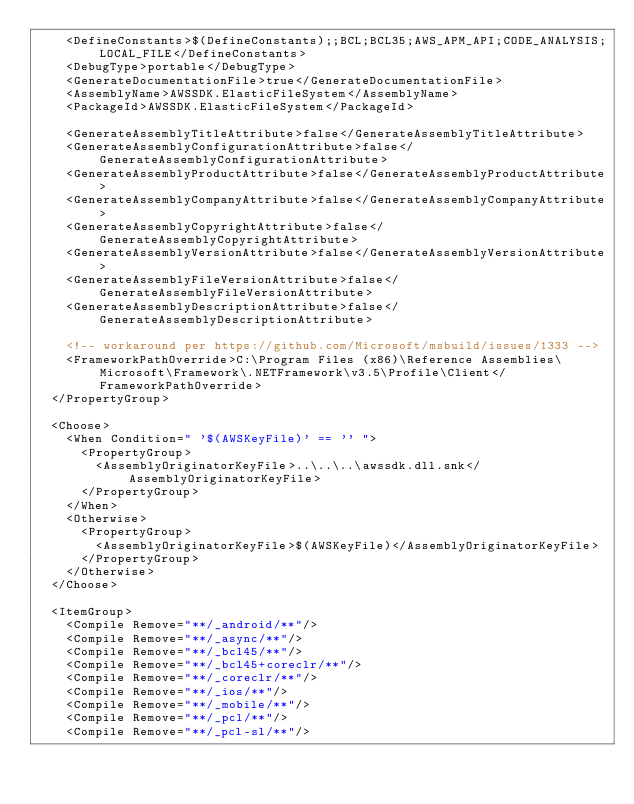Convert code to text. <code><loc_0><loc_0><loc_500><loc_500><_XML_>    <DefineConstants>$(DefineConstants);;BCL;BCL35;AWS_APM_API;CODE_ANALYSIS;LOCAL_FILE</DefineConstants>
    <DebugType>portable</DebugType>
    <GenerateDocumentationFile>true</GenerateDocumentationFile>
    <AssemblyName>AWSSDK.ElasticFileSystem</AssemblyName>
    <PackageId>AWSSDK.ElasticFileSystem</PackageId>

    <GenerateAssemblyTitleAttribute>false</GenerateAssemblyTitleAttribute>
    <GenerateAssemblyConfigurationAttribute>false</GenerateAssemblyConfigurationAttribute>
    <GenerateAssemblyProductAttribute>false</GenerateAssemblyProductAttribute>
    <GenerateAssemblyCompanyAttribute>false</GenerateAssemblyCompanyAttribute>
    <GenerateAssemblyCopyrightAttribute>false</GenerateAssemblyCopyrightAttribute>
    <GenerateAssemblyVersionAttribute>false</GenerateAssemblyVersionAttribute>
    <GenerateAssemblyFileVersionAttribute>false</GenerateAssemblyFileVersionAttribute>
    <GenerateAssemblyDescriptionAttribute>false</GenerateAssemblyDescriptionAttribute>

    <!-- workaround per https://github.com/Microsoft/msbuild/issues/1333 -->
    <FrameworkPathOverride>C:\Program Files (x86)\Reference Assemblies\Microsoft\Framework\.NETFramework\v3.5\Profile\Client</FrameworkPathOverride>
  </PropertyGroup>

  <Choose>
    <When Condition=" '$(AWSKeyFile)' == '' ">
      <PropertyGroup>
        <AssemblyOriginatorKeyFile>..\..\..\awssdk.dll.snk</AssemblyOriginatorKeyFile>
      </PropertyGroup>
    </When>
    <Otherwise>
      <PropertyGroup>
        <AssemblyOriginatorKeyFile>$(AWSKeyFile)</AssemblyOriginatorKeyFile>
      </PropertyGroup>
    </Otherwise>
  </Choose>

  <ItemGroup>
    <Compile Remove="**/_android/**"/>
    <Compile Remove="**/_async/**"/>
    <Compile Remove="**/_bcl45/**"/>
    <Compile Remove="**/_bcl45+coreclr/**"/>
    <Compile Remove="**/_coreclr/**"/>
    <Compile Remove="**/_ios/**"/>
    <Compile Remove="**/_mobile/**"/>
    <Compile Remove="**/_pcl/**"/>
    <Compile Remove="**/_pcl-sl/**"/></code> 